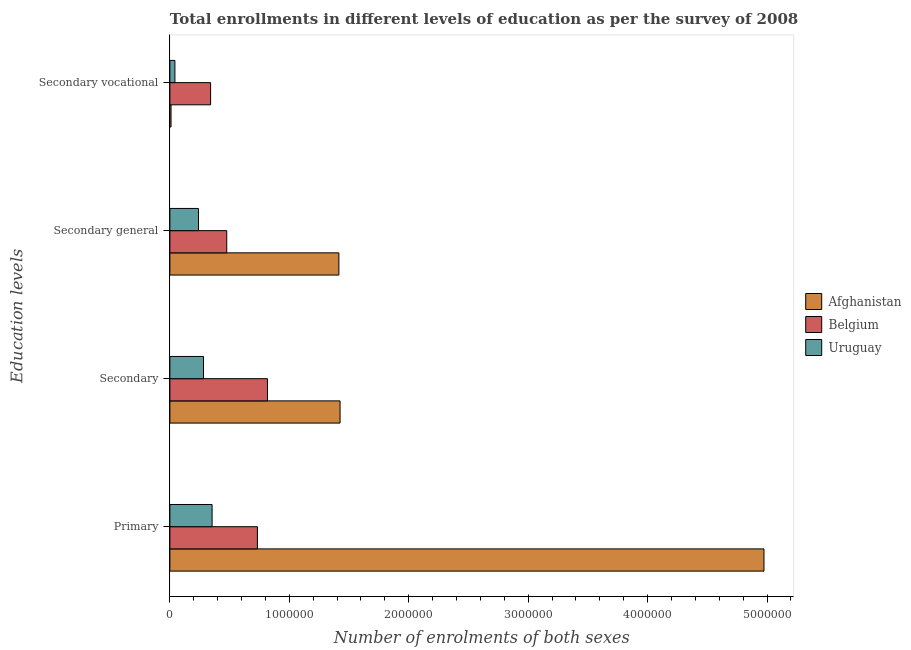How many different coloured bars are there?
Make the answer very short. 3. How many groups of bars are there?
Offer a terse response. 4. Are the number of bars per tick equal to the number of legend labels?
Your response must be concise. Yes. Are the number of bars on each tick of the Y-axis equal?
Ensure brevity in your answer.  Yes. What is the label of the 2nd group of bars from the top?
Provide a succinct answer. Secondary general. What is the number of enrolments in secondary vocational education in Belgium?
Your answer should be compact. 3.41e+05. Across all countries, what is the maximum number of enrolments in secondary vocational education?
Offer a terse response. 3.41e+05. Across all countries, what is the minimum number of enrolments in secondary general education?
Your answer should be very brief. 2.40e+05. In which country was the number of enrolments in secondary general education minimum?
Keep it short and to the point. Uruguay. What is the total number of enrolments in secondary general education in the graph?
Keep it short and to the point. 2.13e+06. What is the difference between the number of enrolments in secondary general education in Afghanistan and that in Uruguay?
Offer a terse response. 1.18e+06. What is the difference between the number of enrolments in secondary general education in Uruguay and the number of enrolments in primary education in Belgium?
Keep it short and to the point. -4.94e+05. What is the average number of enrolments in primary education per country?
Provide a short and direct response. 2.02e+06. What is the difference between the number of enrolments in secondary vocational education and number of enrolments in secondary general education in Afghanistan?
Offer a very short reply. -1.41e+06. What is the ratio of the number of enrolments in secondary education in Belgium to that in Uruguay?
Your response must be concise. 2.9. What is the difference between the highest and the second highest number of enrolments in primary education?
Your response must be concise. 4.24e+06. What is the difference between the highest and the lowest number of enrolments in secondary general education?
Provide a succinct answer. 1.18e+06. What does the 1st bar from the top in Secondary general represents?
Your response must be concise. Uruguay. What does the 3rd bar from the bottom in Primary represents?
Give a very brief answer. Uruguay. How many bars are there?
Your answer should be very brief. 12. Are all the bars in the graph horizontal?
Offer a very short reply. Yes. What is the difference between two consecutive major ticks on the X-axis?
Your response must be concise. 1.00e+06. Does the graph contain grids?
Your answer should be very brief. No. How many legend labels are there?
Your response must be concise. 3. What is the title of the graph?
Your answer should be very brief. Total enrollments in different levels of education as per the survey of 2008. What is the label or title of the X-axis?
Your answer should be compact. Number of enrolments of both sexes. What is the label or title of the Y-axis?
Offer a terse response. Education levels. What is the Number of enrolments of both sexes of Afghanistan in Primary?
Your response must be concise. 4.97e+06. What is the Number of enrolments of both sexes in Belgium in Primary?
Give a very brief answer. 7.33e+05. What is the Number of enrolments of both sexes in Uruguay in Primary?
Your answer should be very brief. 3.54e+05. What is the Number of enrolments of both sexes in Afghanistan in Secondary?
Give a very brief answer. 1.43e+06. What is the Number of enrolments of both sexes in Belgium in Secondary?
Your response must be concise. 8.17e+05. What is the Number of enrolments of both sexes in Uruguay in Secondary?
Offer a very short reply. 2.82e+05. What is the Number of enrolments of both sexes in Afghanistan in Secondary general?
Provide a succinct answer. 1.42e+06. What is the Number of enrolments of both sexes of Belgium in Secondary general?
Provide a succinct answer. 4.76e+05. What is the Number of enrolments of both sexes in Uruguay in Secondary general?
Offer a terse response. 2.40e+05. What is the Number of enrolments of both sexes of Afghanistan in Secondary vocational?
Ensure brevity in your answer.  9716. What is the Number of enrolments of both sexes of Belgium in Secondary vocational?
Provide a short and direct response. 3.41e+05. What is the Number of enrolments of both sexes in Uruguay in Secondary vocational?
Keep it short and to the point. 4.21e+04. Across all Education levels, what is the maximum Number of enrolments of both sexes of Afghanistan?
Ensure brevity in your answer.  4.97e+06. Across all Education levels, what is the maximum Number of enrolments of both sexes of Belgium?
Make the answer very short. 8.17e+05. Across all Education levels, what is the maximum Number of enrolments of both sexes in Uruguay?
Provide a succinct answer. 3.54e+05. Across all Education levels, what is the minimum Number of enrolments of both sexes of Afghanistan?
Your answer should be compact. 9716. Across all Education levels, what is the minimum Number of enrolments of both sexes in Belgium?
Keep it short and to the point. 3.41e+05. Across all Education levels, what is the minimum Number of enrolments of both sexes in Uruguay?
Your answer should be compact. 4.21e+04. What is the total Number of enrolments of both sexes in Afghanistan in the graph?
Offer a terse response. 7.82e+06. What is the total Number of enrolments of both sexes of Belgium in the graph?
Keep it short and to the point. 2.37e+06. What is the total Number of enrolments of both sexes of Uruguay in the graph?
Your response must be concise. 9.17e+05. What is the difference between the Number of enrolments of both sexes in Afghanistan in Primary and that in Secondary?
Offer a terse response. 3.55e+06. What is the difference between the Number of enrolments of both sexes of Belgium in Primary and that in Secondary?
Give a very brief answer. -8.42e+04. What is the difference between the Number of enrolments of both sexes in Uruguay in Primary and that in Secondary?
Ensure brevity in your answer.  7.20e+04. What is the difference between the Number of enrolments of both sexes of Afghanistan in Primary and that in Secondary general?
Make the answer very short. 3.56e+06. What is the difference between the Number of enrolments of both sexes in Belgium in Primary and that in Secondary general?
Ensure brevity in your answer.  2.57e+05. What is the difference between the Number of enrolments of both sexes in Uruguay in Primary and that in Secondary general?
Keep it short and to the point. 1.14e+05. What is the difference between the Number of enrolments of both sexes in Afghanistan in Primary and that in Secondary vocational?
Provide a succinct answer. 4.97e+06. What is the difference between the Number of enrolments of both sexes of Belgium in Primary and that in Secondary vocational?
Keep it short and to the point. 3.92e+05. What is the difference between the Number of enrolments of both sexes of Uruguay in Primary and that in Secondary vocational?
Keep it short and to the point. 3.11e+05. What is the difference between the Number of enrolments of both sexes in Afghanistan in Secondary and that in Secondary general?
Your answer should be compact. 9716. What is the difference between the Number of enrolments of both sexes of Belgium in Secondary and that in Secondary general?
Keep it short and to the point. 3.41e+05. What is the difference between the Number of enrolments of both sexes in Uruguay in Secondary and that in Secondary general?
Provide a short and direct response. 4.21e+04. What is the difference between the Number of enrolments of both sexes in Afghanistan in Secondary and that in Secondary vocational?
Your answer should be very brief. 1.42e+06. What is the difference between the Number of enrolments of both sexes of Belgium in Secondary and that in Secondary vocational?
Your response must be concise. 4.76e+05. What is the difference between the Number of enrolments of both sexes of Uruguay in Secondary and that in Secondary vocational?
Your answer should be compact. 2.40e+05. What is the difference between the Number of enrolments of both sexes in Afghanistan in Secondary general and that in Secondary vocational?
Make the answer very short. 1.41e+06. What is the difference between the Number of enrolments of both sexes of Belgium in Secondary general and that in Secondary vocational?
Offer a very short reply. 1.35e+05. What is the difference between the Number of enrolments of both sexes of Uruguay in Secondary general and that in Secondary vocational?
Provide a short and direct response. 1.97e+05. What is the difference between the Number of enrolments of both sexes in Afghanistan in Primary and the Number of enrolments of both sexes in Belgium in Secondary?
Keep it short and to the point. 4.16e+06. What is the difference between the Number of enrolments of both sexes in Afghanistan in Primary and the Number of enrolments of both sexes in Uruguay in Secondary?
Offer a terse response. 4.69e+06. What is the difference between the Number of enrolments of both sexes in Belgium in Primary and the Number of enrolments of both sexes in Uruguay in Secondary?
Provide a short and direct response. 4.51e+05. What is the difference between the Number of enrolments of both sexes in Afghanistan in Primary and the Number of enrolments of both sexes in Belgium in Secondary general?
Your response must be concise. 4.50e+06. What is the difference between the Number of enrolments of both sexes of Afghanistan in Primary and the Number of enrolments of both sexes of Uruguay in Secondary general?
Offer a terse response. 4.74e+06. What is the difference between the Number of enrolments of both sexes of Belgium in Primary and the Number of enrolments of both sexes of Uruguay in Secondary general?
Make the answer very short. 4.94e+05. What is the difference between the Number of enrolments of both sexes in Afghanistan in Primary and the Number of enrolments of both sexes in Belgium in Secondary vocational?
Offer a very short reply. 4.63e+06. What is the difference between the Number of enrolments of both sexes in Afghanistan in Primary and the Number of enrolments of both sexes in Uruguay in Secondary vocational?
Offer a terse response. 4.93e+06. What is the difference between the Number of enrolments of both sexes in Belgium in Primary and the Number of enrolments of both sexes in Uruguay in Secondary vocational?
Ensure brevity in your answer.  6.91e+05. What is the difference between the Number of enrolments of both sexes of Afghanistan in Secondary and the Number of enrolments of both sexes of Belgium in Secondary general?
Your response must be concise. 9.49e+05. What is the difference between the Number of enrolments of both sexes of Afghanistan in Secondary and the Number of enrolments of both sexes of Uruguay in Secondary general?
Your answer should be very brief. 1.19e+06. What is the difference between the Number of enrolments of both sexes of Belgium in Secondary and the Number of enrolments of both sexes of Uruguay in Secondary general?
Your answer should be compact. 5.78e+05. What is the difference between the Number of enrolments of both sexes of Afghanistan in Secondary and the Number of enrolments of both sexes of Belgium in Secondary vocational?
Your answer should be compact. 1.08e+06. What is the difference between the Number of enrolments of both sexes of Afghanistan in Secondary and the Number of enrolments of both sexes of Uruguay in Secondary vocational?
Your answer should be very brief. 1.38e+06. What is the difference between the Number of enrolments of both sexes of Belgium in Secondary and the Number of enrolments of both sexes of Uruguay in Secondary vocational?
Keep it short and to the point. 7.75e+05. What is the difference between the Number of enrolments of both sexes in Afghanistan in Secondary general and the Number of enrolments of both sexes in Belgium in Secondary vocational?
Give a very brief answer. 1.07e+06. What is the difference between the Number of enrolments of both sexes of Afghanistan in Secondary general and the Number of enrolments of both sexes of Uruguay in Secondary vocational?
Offer a terse response. 1.37e+06. What is the difference between the Number of enrolments of both sexes in Belgium in Secondary general and the Number of enrolments of both sexes in Uruguay in Secondary vocational?
Provide a succinct answer. 4.34e+05. What is the average Number of enrolments of both sexes in Afghanistan per Education levels?
Provide a succinct answer. 1.96e+06. What is the average Number of enrolments of both sexes of Belgium per Education levels?
Make the answer very short. 5.92e+05. What is the average Number of enrolments of both sexes of Uruguay per Education levels?
Ensure brevity in your answer.  2.29e+05. What is the difference between the Number of enrolments of both sexes of Afghanistan and Number of enrolments of both sexes of Belgium in Primary?
Ensure brevity in your answer.  4.24e+06. What is the difference between the Number of enrolments of both sexes of Afghanistan and Number of enrolments of both sexes of Uruguay in Primary?
Keep it short and to the point. 4.62e+06. What is the difference between the Number of enrolments of both sexes of Belgium and Number of enrolments of both sexes of Uruguay in Primary?
Offer a terse response. 3.79e+05. What is the difference between the Number of enrolments of both sexes of Afghanistan and Number of enrolments of both sexes of Belgium in Secondary?
Provide a succinct answer. 6.08e+05. What is the difference between the Number of enrolments of both sexes in Afghanistan and Number of enrolments of both sexes in Uruguay in Secondary?
Your answer should be compact. 1.14e+06. What is the difference between the Number of enrolments of both sexes of Belgium and Number of enrolments of both sexes of Uruguay in Secondary?
Keep it short and to the point. 5.36e+05. What is the difference between the Number of enrolments of both sexes in Afghanistan and Number of enrolments of both sexes in Belgium in Secondary general?
Provide a short and direct response. 9.39e+05. What is the difference between the Number of enrolments of both sexes in Afghanistan and Number of enrolments of both sexes in Uruguay in Secondary general?
Keep it short and to the point. 1.18e+06. What is the difference between the Number of enrolments of both sexes in Belgium and Number of enrolments of both sexes in Uruguay in Secondary general?
Give a very brief answer. 2.37e+05. What is the difference between the Number of enrolments of both sexes in Afghanistan and Number of enrolments of both sexes in Belgium in Secondary vocational?
Your answer should be very brief. -3.31e+05. What is the difference between the Number of enrolments of both sexes in Afghanistan and Number of enrolments of both sexes in Uruguay in Secondary vocational?
Provide a succinct answer. -3.24e+04. What is the difference between the Number of enrolments of both sexes in Belgium and Number of enrolments of both sexes in Uruguay in Secondary vocational?
Give a very brief answer. 2.99e+05. What is the ratio of the Number of enrolments of both sexes of Afghanistan in Primary to that in Secondary?
Keep it short and to the point. 3.49. What is the ratio of the Number of enrolments of both sexes of Belgium in Primary to that in Secondary?
Provide a short and direct response. 0.9. What is the ratio of the Number of enrolments of both sexes of Uruguay in Primary to that in Secondary?
Provide a short and direct response. 1.26. What is the ratio of the Number of enrolments of both sexes of Afghanistan in Primary to that in Secondary general?
Your answer should be compact. 3.52. What is the ratio of the Number of enrolments of both sexes in Belgium in Primary to that in Secondary general?
Give a very brief answer. 1.54. What is the ratio of the Number of enrolments of both sexes of Uruguay in Primary to that in Secondary general?
Give a very brief answer. 1.48. What is the ratio of the Number of enrolments of both sexes of Afghanistan in Primary to that in Secondary vocational?
Your answer should be compact. 512.03. What is the ratio of the Number of enrolments of both sexes of Belgium in Primary to that in Secondary vocational?
Your answer should be compact. 2.15. What is the ratio of the Number of enrolments of both sexes of Uruguay in Primary to that in Secondary vocational?
Your answer should be very brief. 8.4. What is the ratio of the Number of enrolments of both sexes in Belgium in Secondary to that in Secondary general?
Your answer should be very brief. 1.72. What is the ratio of the Number of enrolments of both sexes of Uruguay in Secondary to that in Secondary general?
Your answer should be very brief. 1.18. What is the ratio of the Number of enrolments of both sexes of Afghanistan in Secondary to that in Secondary vocational?
Your answer should be compact. 146.67. What is the ratio of the Number of enrolments of both sexes in Belgium in Secondary to that in Secondary vocational?
Provide a succinct answer. 2.4. What is the ratio of the Number of enrolments of both sexes of Uruguay in Secondary to that in Secondary vocational?
Offer a terse response. 6.69. What is the ratio of the Number of enrolments of both sexes of Afghanistan in Secondary general to that in Secondary vocational?
Keep it short and to the point. 145.67. What is the ratio of the Number of enrolments of both sexes in Belgium in Secondary general to that in Secondary vocational?
Offer a very short reply. 1.4. What is the ratio of the Number of enrolments of both sexes of Uruguay in Secondary general to that in Secondary vocational?
Give a very brief answer. 5.69. What is the difference between the highest and the second highest Number of enrolments of both sexes of Afghanistan?
Make the answer very short. 3.55e+06. What is the difference between the highest and the second highest Number of enrolments of both sexes of Belgium?
Your response must be concise. 8.42e+04. What is the difference between the highest and the second highest Number of enrolments of both sexes in Uruguay?
Provide a short and direct response. 7.20e+04. What is the difference between the highest and the lowest Number of enrolments of both sexes in Afghanistan?
Give a very brief answer. 4.97e+06. What is the difference between the highest and the lowest Number of enrolments of both sexes of Belgium?
Ensure brevity in your answer.  4.76e+05. What is the difference between the highest and the lowest Number of enrolments of both sexes of Uruguay?
Your answer should be very brief. 3.11e+05. 